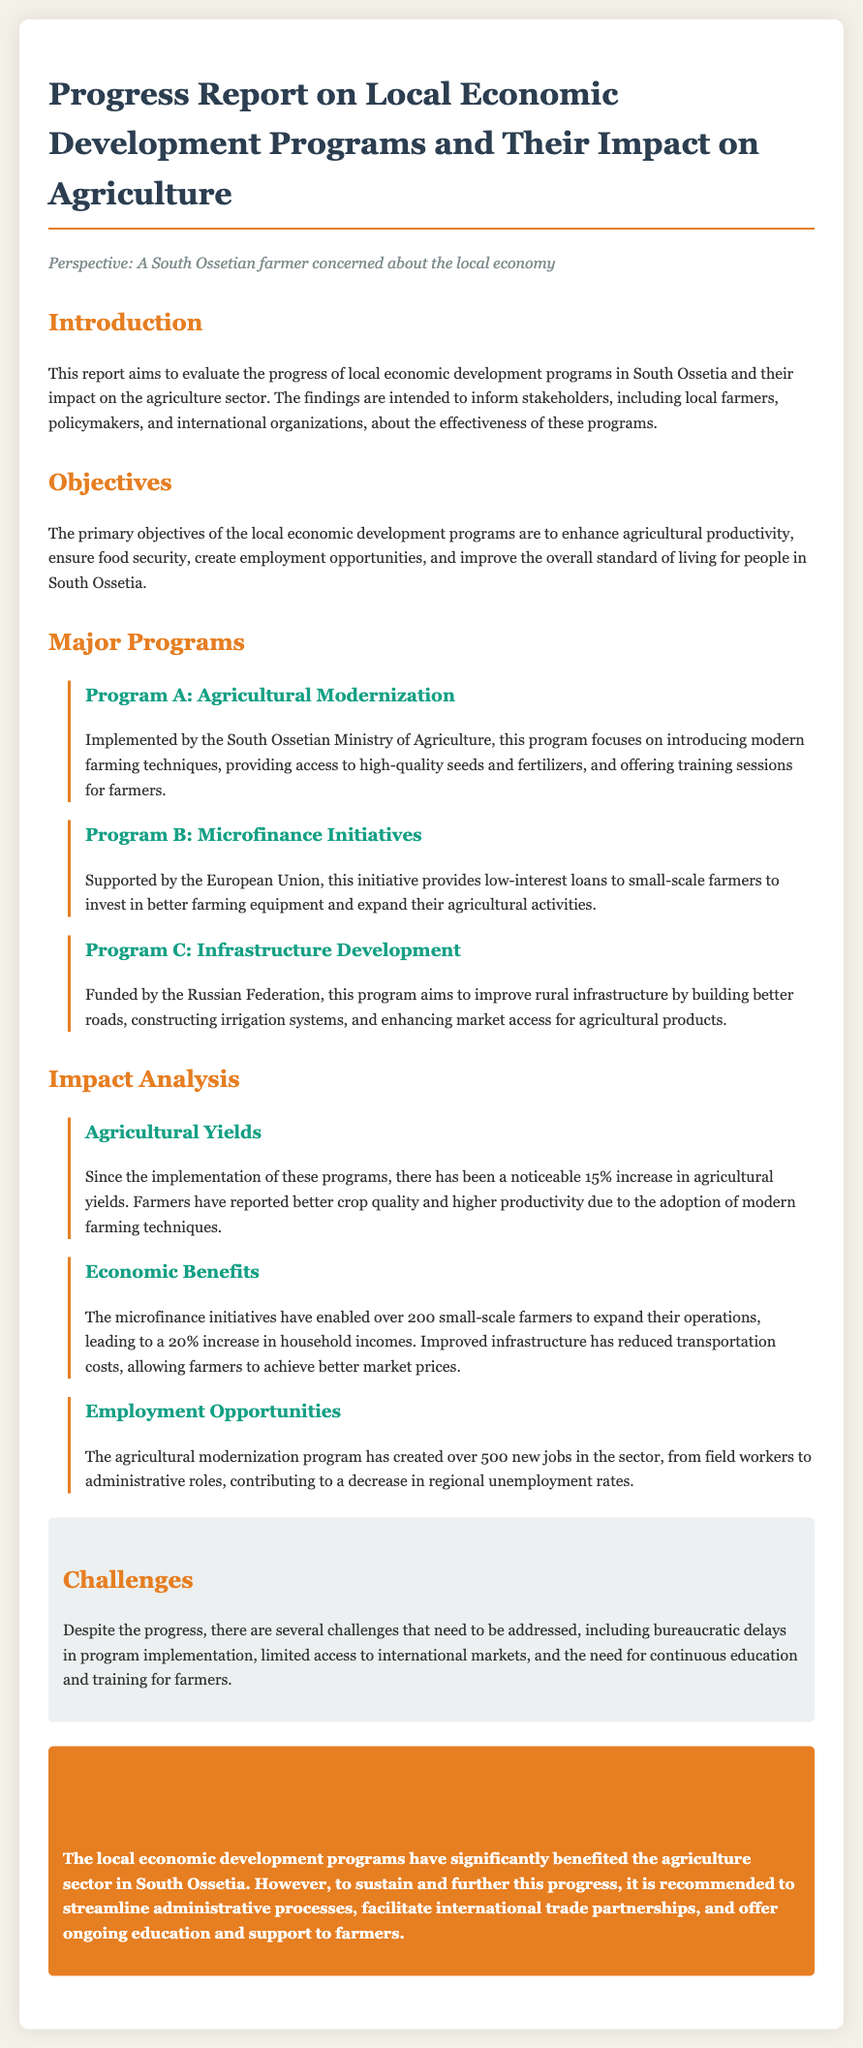What is the purpose of the report? The purpose of the report is to evaluate the progress of local economic development programs in South Ossetia and their impact on the agriculture sector.
Answer: Evaluate progress What percentage increase has been observed in agricultural yields? The document states that there has been a noticeable 15% increase in agricultural yields.
Answer: 15% Which program is implemented by the South Ossetian Ministry of Agriculture? Program A, which is focused on agricultural modernization, is implemented by the South Ossetian Ministry of Agriculture.
Answer: Program A How many jobs have been created by the agricultural modernization program? The agricultural modernization program has created over 500 new jobs in the sector.
Answer: 500 jobs What is one of the challenges faced in the local economic development programs? The challenges include bureaucratic delays in program implementation.
Answer: Bureaucratic delays What was the effect of microfinance initiatives on household incomes? The microfinance initiatives led to a 20% increase in household incomes for farmers.
Answer: 20% increase Which program aims to improve rural infrastructure? Program C focuses on infrastructure development, aiming to improve rural infrastructure.
Answer: Program C What is recommended to sustain progress in local economic development? It is recommended to streamline administrative processes and facilitate international trade partnerships.
Answer: Streamline processes 